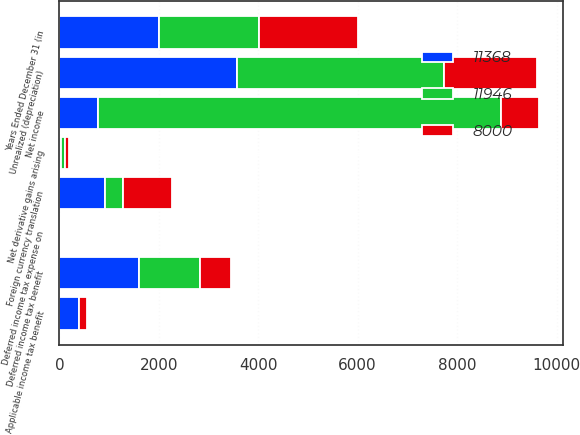<chart> <loc_0><loc_0><loc_500><loc_500><stacked_bar_chart><ecel><fcel>Years Ended December 31 (in<fcel>Net income<fcel>Unrealized (depreciation)<fcel>Deferred income tax benefit<fcel>Foreign currency translation<fcel>Applicable income tax benefit<fcel>Net derivative gains arising<fcel>Deferred income tax expense on<nl><fcel>11368<fcel>2005<fcel>769<fcel>3577<fcel>1599<fcel>926<fcel>386<fcel>35<fcel>7<nl><fcel>8000<fcel>2004<fcel>769<fcel>1868<fcel>612<fcel>993<fcel>170<fcel>83<fcel>33<nl><fcel>11946<fcel>2003<fcel>8108<fcel>4159<fcel>1237<fcel>347<fcel>4<fcel>75<fcel>22<nl></chart> 